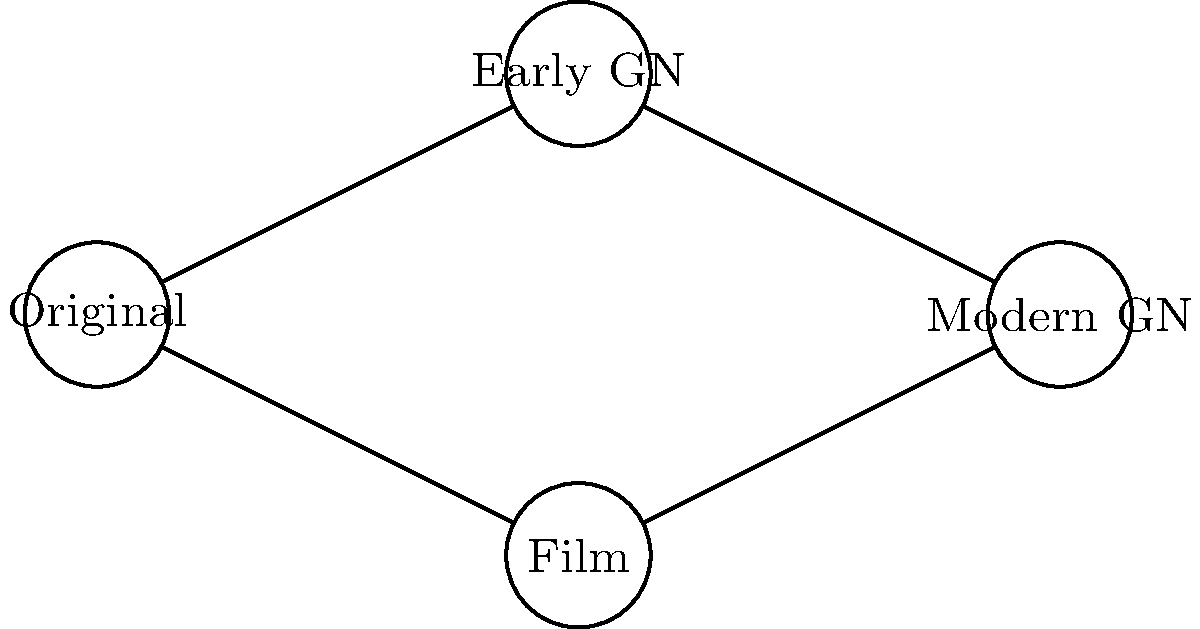In the evolution of character design from classic literature to graphic novels, which path in the network diagram represents the most faithful progression in terms of maintaining the essence of the original character descriptions while adapting to modern visual storytelling techniques? To answer this question, we need to analyze the network diagram and consider the progression of character design from classic literature to modern graphic novels. Let's break down the paths:

1. Original → Early GN → Modern GN:
   This path represents a gradual evolution from the original literary descriptions to early graphic novel adaptations, and then to modern graphic novel representations. This progression allows for a step-by-step adaptation of the character, potentially preserving more of the original essence while slowly incorporating modern visual elements.

2. Original → Film → Modern GN:
   This path bypasses early graphic novel adaptations and goes through film representations before reaching modern graphic novels. While films can be faithful to original descriptions, they often take more liberties with character design due to practical constraints and the different nature of the medium.

3. Original → Early GN → Film → Modern GN:
   This path is not directly shown in the diagram but could be inferred. It would represent a more complex evolution, potentially diverging further from the original descriptions due to multiple adaptations across different media.

Considering the persona of a graphic novel enthusiast who appreciates the interplay between classic literature and modern adaptations, while being conservative about explicit content, the most faithful progression would likely be the path that allows for a gradual evolution while staying closest to the source material.

Therefore, the path Original → Early GN → Modern GN represents the most faithful progression. This path allows for:
1. Initial adaptation to the graphic novel format while staying close to original descriptions
2. Gradual incorporation of modern visual storytelling techniques
3. Potential preservation of the character's essence throughout the evolution

This path minimizes the risk of drastic changes that might occur when adapting to film before graphic novels, and allows for a more controlled and respectful evolution of the character design.
Answer: Original → Early GN → Modern GN 